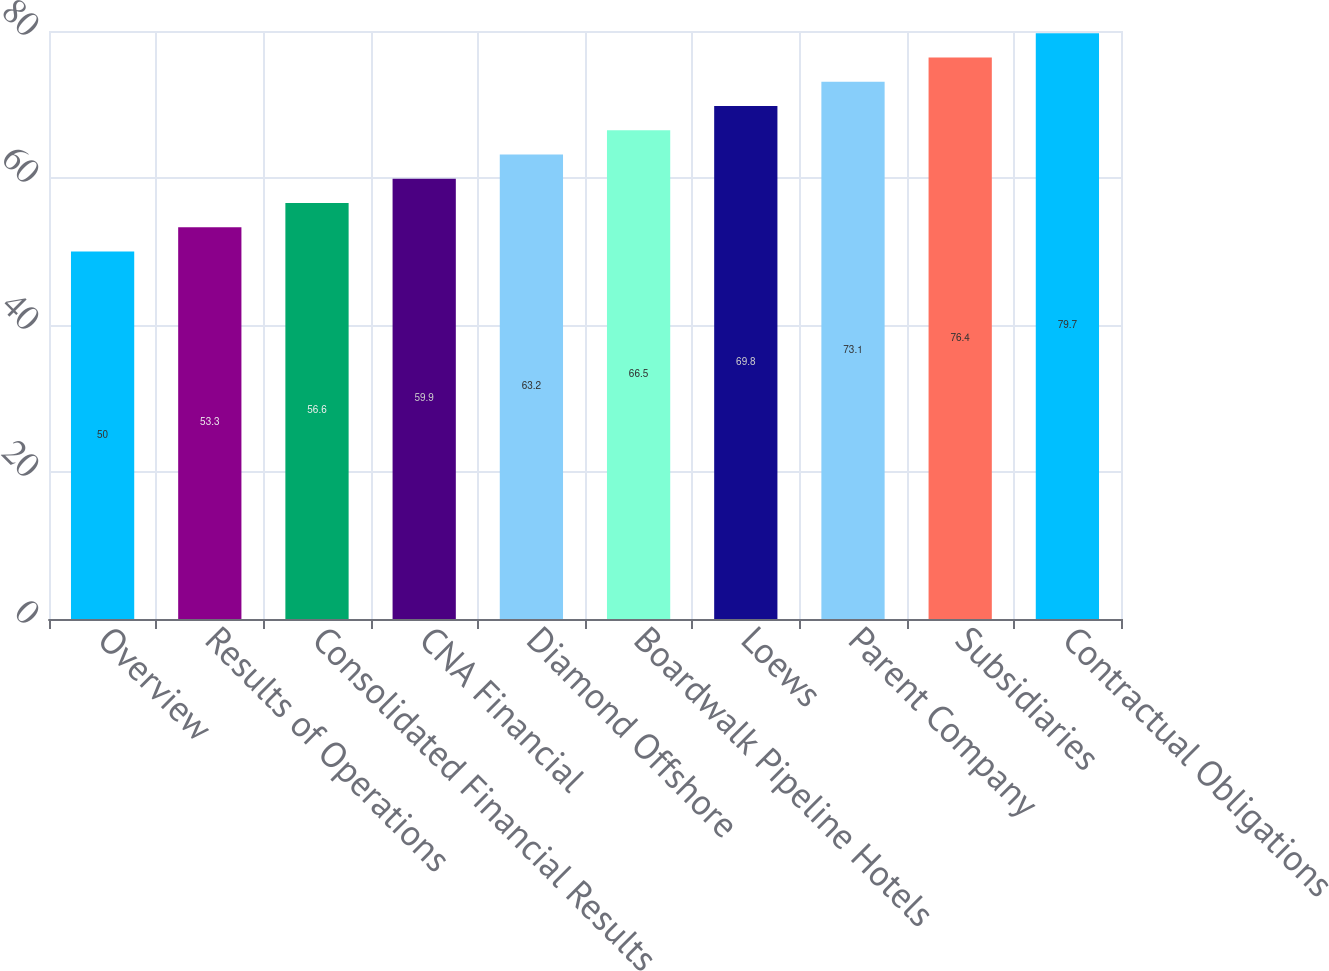<chart> <loc_0><loc_0><loc_500><loc_500><bar_chart><fcel>Overview<fcel>Results of Operations<fcel>Consolidated Financial Results<fcel>CNA Financial<fcel>Diamond Offshore<fcel>Boardwalk Pipeline Hotels<fcel>Loews<fcel>Parent Company<fcel>Subsidiaries<fcel>Contractual Obligations<nl><fcel>50<fcel>53.3<fcel>56.6<fcel>59.9<fcel>63.2<fcel>66.5<fcel>69.8<fcel>73.1<fcel>76.4<fcel>79.7<nl></chart> 